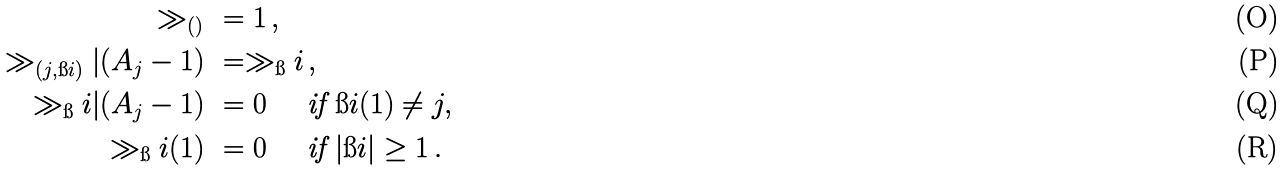Convert formula to latex. <formula><loc_0><loc_0><loc_500><loc_500>\gg _ { ( ) } & \ = 1 \, , \\ \gg _ { ( j , \i i ) } | ( A _ { j } - 1 ) & \ = \gg _ { \i } i \, , \\ \gg _ { \i } i | ( A _ { j } - 1 ) & \ = 0 \quad \text { if } \i i ( 1 ) \neq j , \\ \gg _ { \i } i ( 1 ) & \ = 0 \quad \text { if } | \i i | \geq 1 \, .</formula> 